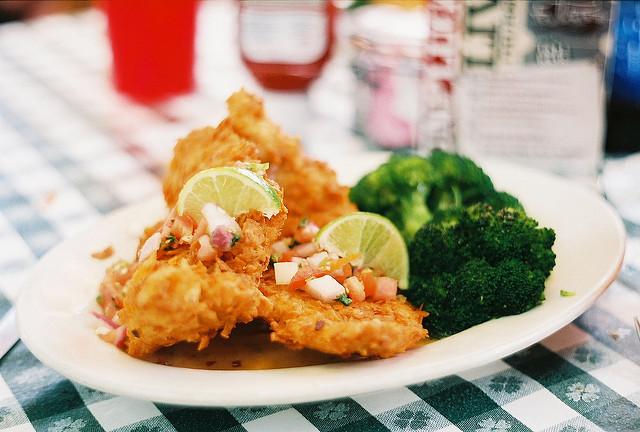Is the broccoli green?
Give a very brief answer. Yes. What kind of vegetable is on the plate?
Write a very short answer. Broccoli. Are there people in the image?
Keep it brief. No. Where is the ketchup bottle?
Give a very brief answer. On table. What would you do with the limes in this picture?
Answer briefly. Squeeze. 